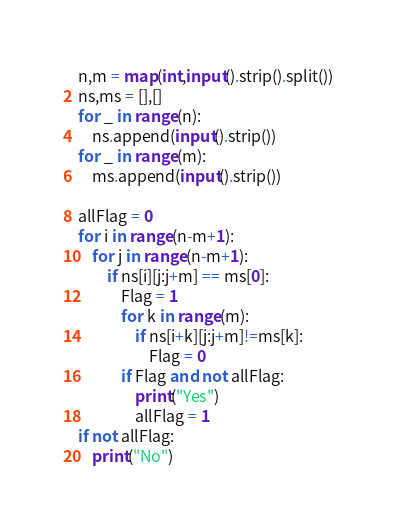<code> <loc_0><loc_0><loc_500><loc_500><_Python_>n,m = map(int,input().strip().split())
ns,ms = [],[]
for _ in range(n):
    ns.append(input().strip())
for _ in range(m):
    ms.append(input().strip())

allFlag = 0
for i in range(n-m+1):
    for j in range(n-m+1):
        if ns[i][j:j+m] == ms[0]:
            Flag = 1
            for k in range(m):
                if ns[i+k][j:j+m]!=ms[k]:
                    Flag = 0
            if Flag and not allFlag:
                print("Yes")
                allFlag = 1
if not allFlag:
    print("No")</code> 